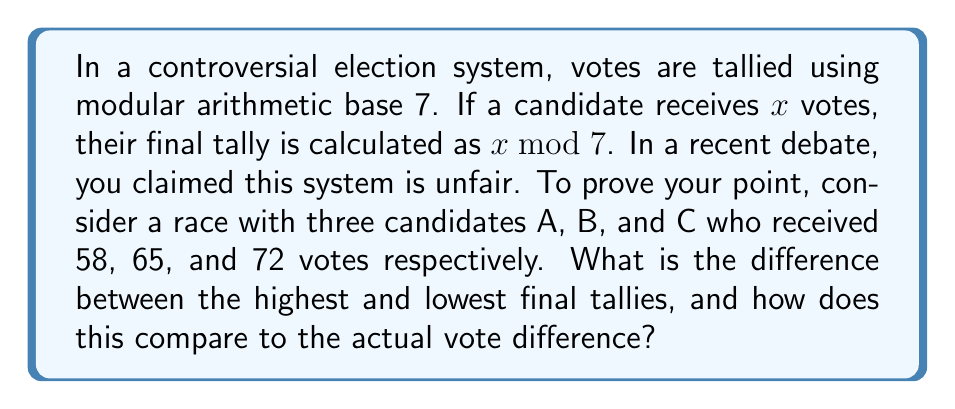Give your solution to this math problem. Let's approach this step-by-step:

1) First, we need to calculate the final tally for each candidate using modular arithmetic base 7.

   For Candidate A: $58 \bmod 7 = 2$
   Because $58 = 7 \times 8 + 2$

   For Candidate B: $65 \bmod 7 = 2$
   Because $65 = 7 \times 9 + 2$

   For Candidate C: $72 \bmod 7 = 0$
   Because $72 = 7 \times 10 + 0$

2) Now we can see that the highest final tally is 2 and the lowest is 0.

3) The difference between the highest and lowest final tallies is:
   $2 - 0 = 2$

4) To compare this with the actual vote difference:
   The highest actual vote count was 72 (Candidate C)
   The lowest actual vote count was 58 (Candidate A)
   
   Actual vote difference: $72 - 58 = 14$

5) The modular arithmetic system reduced a 14-vote difference to a 2-point difference in the final tally.

This demonstrates how the modular arithmetic system can significantly distort the actual voting results, potentially leading to unfair outcomes.
Answer: The difference between the highest and lowest final tallies is 2, while the actual vote difference was 14. This shows a significant reduction in the vote difference, supporting the claim that the system is unfair. 